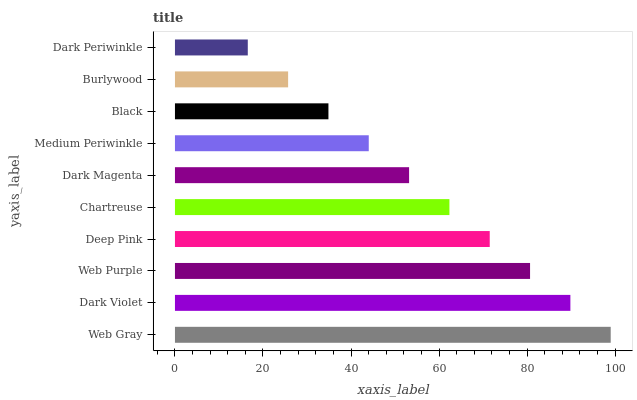Is Dark Periwinkle the minimum?
Answer yes or no. Yes. Is Web Gray the maximum?
Answer yes or no. Yes. Is Dark Violet the minimum?
Answer yes or no. No. Is Dark Violet the maximum?
Answer yes or no. No. Is Web Gray greater than Dark Violet?
Answer yes or no. Yes. Is Dark Violet less than Web Gray?
Answer yes or no. Yes. Is Dark Violet greater than Web Gray?
Answer yes or no. No. Is Web Gray less than Dark Violet?
Answer yes or no. No. Is Chartreuse the high median?
Answer yes or no. Yes. Is Dark Magenta the low median?
Answer yes or no. Yes. Is Dark Violet the high median?
Answer yes or no. No. Is Web Purple the low median?
Answer yes or no. No. 